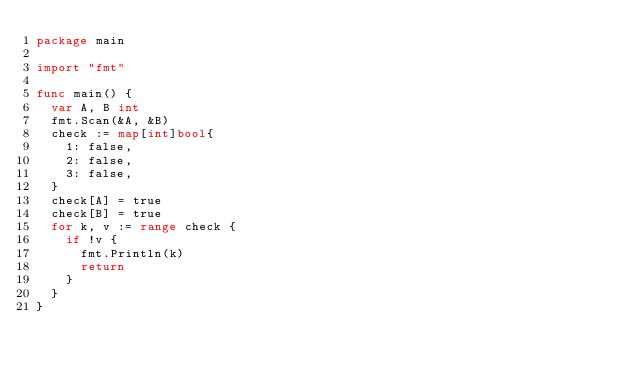Convert code to text. <code><loc_0><loc_0><loc_500><loc_500><_Go_>package main

import "fmt"

func main() {
	var A, B int
	fmt.Scan(&A, &B)
	check := map[int]bool{
		1: false,
		2: false,
		3: false,
	}
	check[A] = true
	check[B] = true
	for k, v := range check {
		if !v {
			fmt.Println(k)
			return
		}
	}
}
</code> 